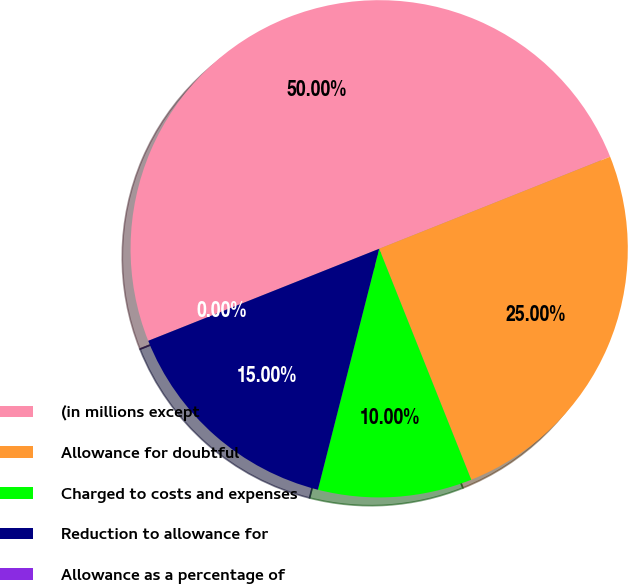Convert chart. <chart><loc_0><loc_0><loc_500><loc_500><pie_chart><fcel>(in millions except<fcel>Allowance for doubtful<fcel>Charged to costs and expenses<fcel>Reduction to allowance for<fcel>Allowance as a percentage of<nl><fcel>50.0%<fcel>25.0%<fcel>10.0%<fcel>15.0%<fcel>0.0%<nl></chart> 